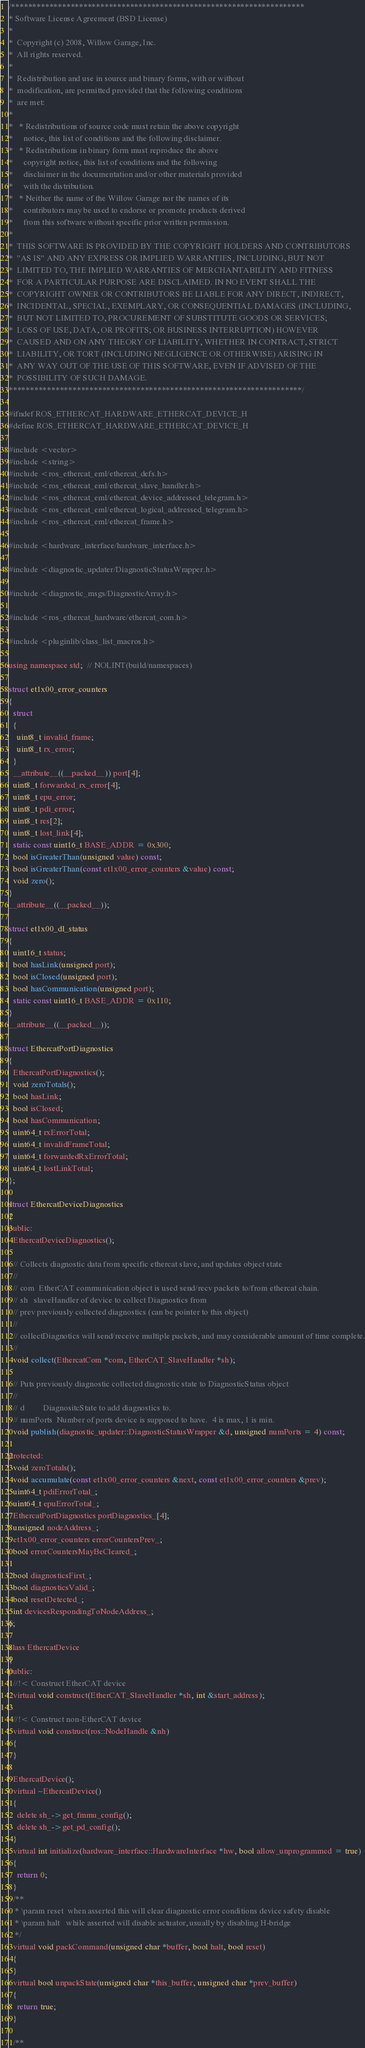<code> <loc_0><loc_0><loc_500><loc_500><_C_>/*********************************************************************
* Software License Agreement (BSD License)
*
*  Copyright (c) 2008, Willow Garage, Inc.
*  All rights reserved.
*
*  Redistribution and use in source and binary forms, with or without
*  modification, are permitted provided that the following conditions
*  are met:
*
*   * Redistributions of source code must retain the above copyright
*     notice, this list of conditions and the following disclaimer.
*   * Redistributions in binary form must reproduce the above
*     copyright notice, this list of conditions and the following
*     disclaimer in the documentation and/or other materials provided
*     with the distribution.
*   * Neither the name of the Willow Garage nor the names of its
*     contributors may be used to endorse or promote products derived
*     from this software without specific prior written permission.
*
*  THIS SOFTWARE IS PROVIDED BY THE COPYRIGHT HOLDERS AND CONTRIBUTORS
*  "AS IS" AND ANY EXPRESS OR IMPLIED WARRANTIES, INCLUDING, BUT NOT
*  LIMITED TO, THE IMPLIED WARRANTIES OF MERCHANTABILITY AND FITNESS
*  FOR A PARTICULAR PURPOSE ARE DISCLAIMED. IN NO EVENT SHALL THE
*  COPYRIGHT OWNER OR CONTRIBUTORS BE LIABLE FOR ANY DIRECT, INDIRECT,
*  INCIDENTAL, SPECIAL, EXEMPLARY, OR CONSEQUENTIAL DAMAGES (INCLUDING,
*  BUT NOT LIMITED TO, PROCUREMENT OF SUBSTITUTE GOODS OR SERVICES;
*  LOSS OF USE, DATA, OR PROFITS; OR BUSINESS INTERRUPTION) HOWEVER
*  CAUSED AND ON ANY THEORY OF LIABILITY, WHETHER IN CONTRACT, STRICT
*  LIABILITY, OR TORT (INCLUDING NEGLIGENCE OR OTHERWISE) ARISING IN
*  ANY WAY OUT OF THE USE OF THIS SOFTWARE, EVEN IF ADVISED OF THE
*  POSSIBILITY OF SUCH DAMAGE.
*********************************************************************/

#ifndef ROS_ETHERCAT_HARDWARE_ETHERCAT_DEVICE_H
#define ROS_ETHERCAT_HARDWARE_ETHERCAT_DEVICE_H

#include <vector>
#include <string>
#include <ros_ethercat_eml/ethercat_defs.h>
#include <ros_ethercat_eml/ethercat_slave_handler.h>
#include <ros_ethercat_eml/ethercat_device_addressed_telegram.h>
#include <ros_ethercat_eml/ethercat_logical_addressed_telegram.h>
#include <ros_ethercat_eml/ethercat_frame.h>

#include <hardware_interface/hardware_interface.h>

#include <diagnostic_updater/DiagnosticStatusWrapper.h>

#include <diagnostic_msgs/DiagnosticArray.h>

#include <ros_ethercat_hardware/ethercat_com.h>

#include <pluginlib/class_list_macros.h>

using namespace std;  // NOLINT(build/namespaces)

struct et1x00_error_counters
{
  struct
  {
    uint8_t invalid_frame;
    uint8_t rx_error;
  }
  __attribute__((__packed__)) port[4];
  uint8_t forwarded_rx_error[4];
  uint8_t epu_error;
  uint8_t pdi_error;
  uint8_t res[2];
  uint8_t lost_link[4];
  static const uint16_t BASE_ADDR = 0x300;
  bool isGreaterThan(unsigned value) const;
  bool isGreaterThan(const et1x00_error_counters &value) const;
  void zero();
}
__attribute__((__packed__));

struct et1x00_dl_status
{
  uint16_t status;
  bool hasLink(unsigned port);
  bool isClosed(unsigned port);
  bool hasCommunication(unsigned port);
  static const uint16_t BASE_ADDR = 0x110;
}
__attribute__((__packed__));

struct EthercatPortDiagnostics
{
  EthercatPortDiagnostics();
  void zeroTotals();
  bool hasLink;
  bool isClosed;
  bool hasCommunication;
  uint64_t rxErrorTotal;
  uint64_t invalidFrameTotal;
  uint64_t forwardedRxErrorTotal;
  uint64_t lostLinkTotal;
};

struct EthercatDeviceDiagnostics
{
public:
  EthercatDeviceDiagnostics();

  // Collects diagnostic data from specific ethercat slave, and updates object state
  //
  // com  EtherCAT communication object is used send/recv packets to/from ethercat chain.
  // sh   slaveHandler of device to collect Diagnostics from
  // prev previously collected diagnostics (can be pointer to this object)
  //
  // collectDiagnotics will send/receive multiple packets, and may considerable amount of time complete.
  //
  void collect(EthercatCom *com, EtherCAT_SlaveHandler *sh);

  // Puts previously diagnostic collected diagnostic state to DiagnosticStatus object
  //
  // d         DiagnositcState to add diagnostics to.
  // numPorts  Number of ports device is supposed to have.  4 is max, 1 is min.
  void publish(diagnostic_updater::DiagnosticStatusWrapper &d, unsigned numPorts = 4) const;

protected:
  void zeroTotals();
  void accumulate(const et1x00_error_counters &next, const et1x00_error_counters &prev);
  uint64_t pdiErrorTotal_;
  uint64_t epuErrorTotal_;
  EthercatPortDiagnostics portDiagnostics_[4];
  unsigned nodeAddress_;
  et1x00_error_counters errorCountersPrev_;
  bool errorCountersMayBeCleared_;

  bool diagnosticsFirst_;
  bool diagnosticsValid_;
  bool resetDetected_;
  int devicesRespondingToNodeAddress_;
};

class EthercatDevice
{
public:
  //!< Construct EtherCAT device
  virtual void construct(EtherCAT_SlaveHandler *sh, int &start_address);

  //!< Construct non-EtherCAT device
  virtual void construct(ros::NodeHandle &nh)
  {
  }

  EthercatDevice();
  virtual ~EthercatDevice()
  {
    delete sh_->get_fmmu_config();
    delete sh_->get_pd_config();
  }
  virtual int initialize(hardware_interface::HardwareInterface *hw, bool allow_unprogrammed = true)
  {
    return 0;
  }
  /**
   * \param reset  when asserted this will clear diagnostic error conditions device safety disable
   * \param halt   while asserted will disable actuator, usually by disabling H-bridge
   */
  virtual void packCommand(unsigned char *buffer, bool halt, bool reset)
  {
  }
  virtual bool unpackState(unsigned char *this_buffer, unsigned char *prev_buffer)
  {
    return true;
  }

  /**</code> 